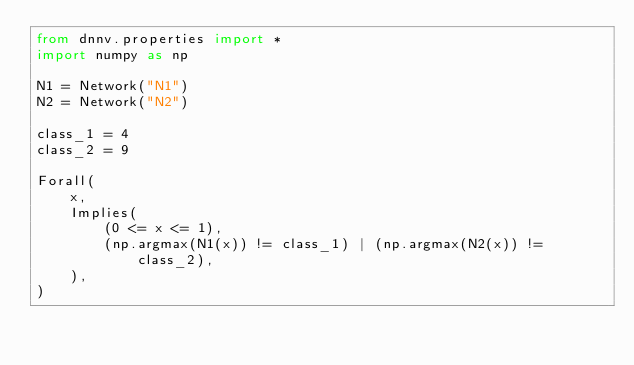<code> <loc_0><loc_0><loc_500><loc_500><_Python_>from dnnv.properties import *
import numpy as np

N1 = Network("N1")
N2 = Network("N2")

class_1 = 4
class_2 = 9

Forall(
    x,
    Implies(
        (0 <= x <= 1),
        (np.argmax(N1(x)) != class_1) | (np.argmax(N2(x)) != class_2),
    ),
)
</code> 